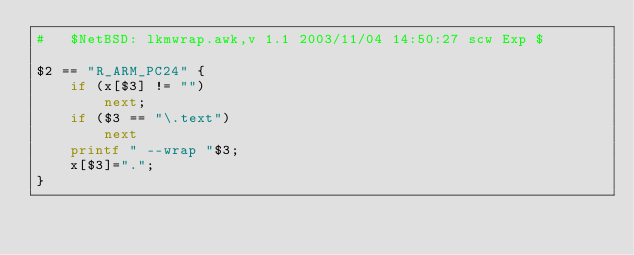Convert code to text. <code><loc_0><loc_0><loc_500><loc_500><_Awk_>#	$NetBSD: lkmwrap.awk,v 1.1 2003/11/04 14:50:27 scw Exp $

$2 == "R_ARM_PC24" {
	if (x[$3] != "")
		next;
	if ($3 == "\.text")
		next
	printf " --wrap "$3;
	x[$3]=".";
}
</code> 